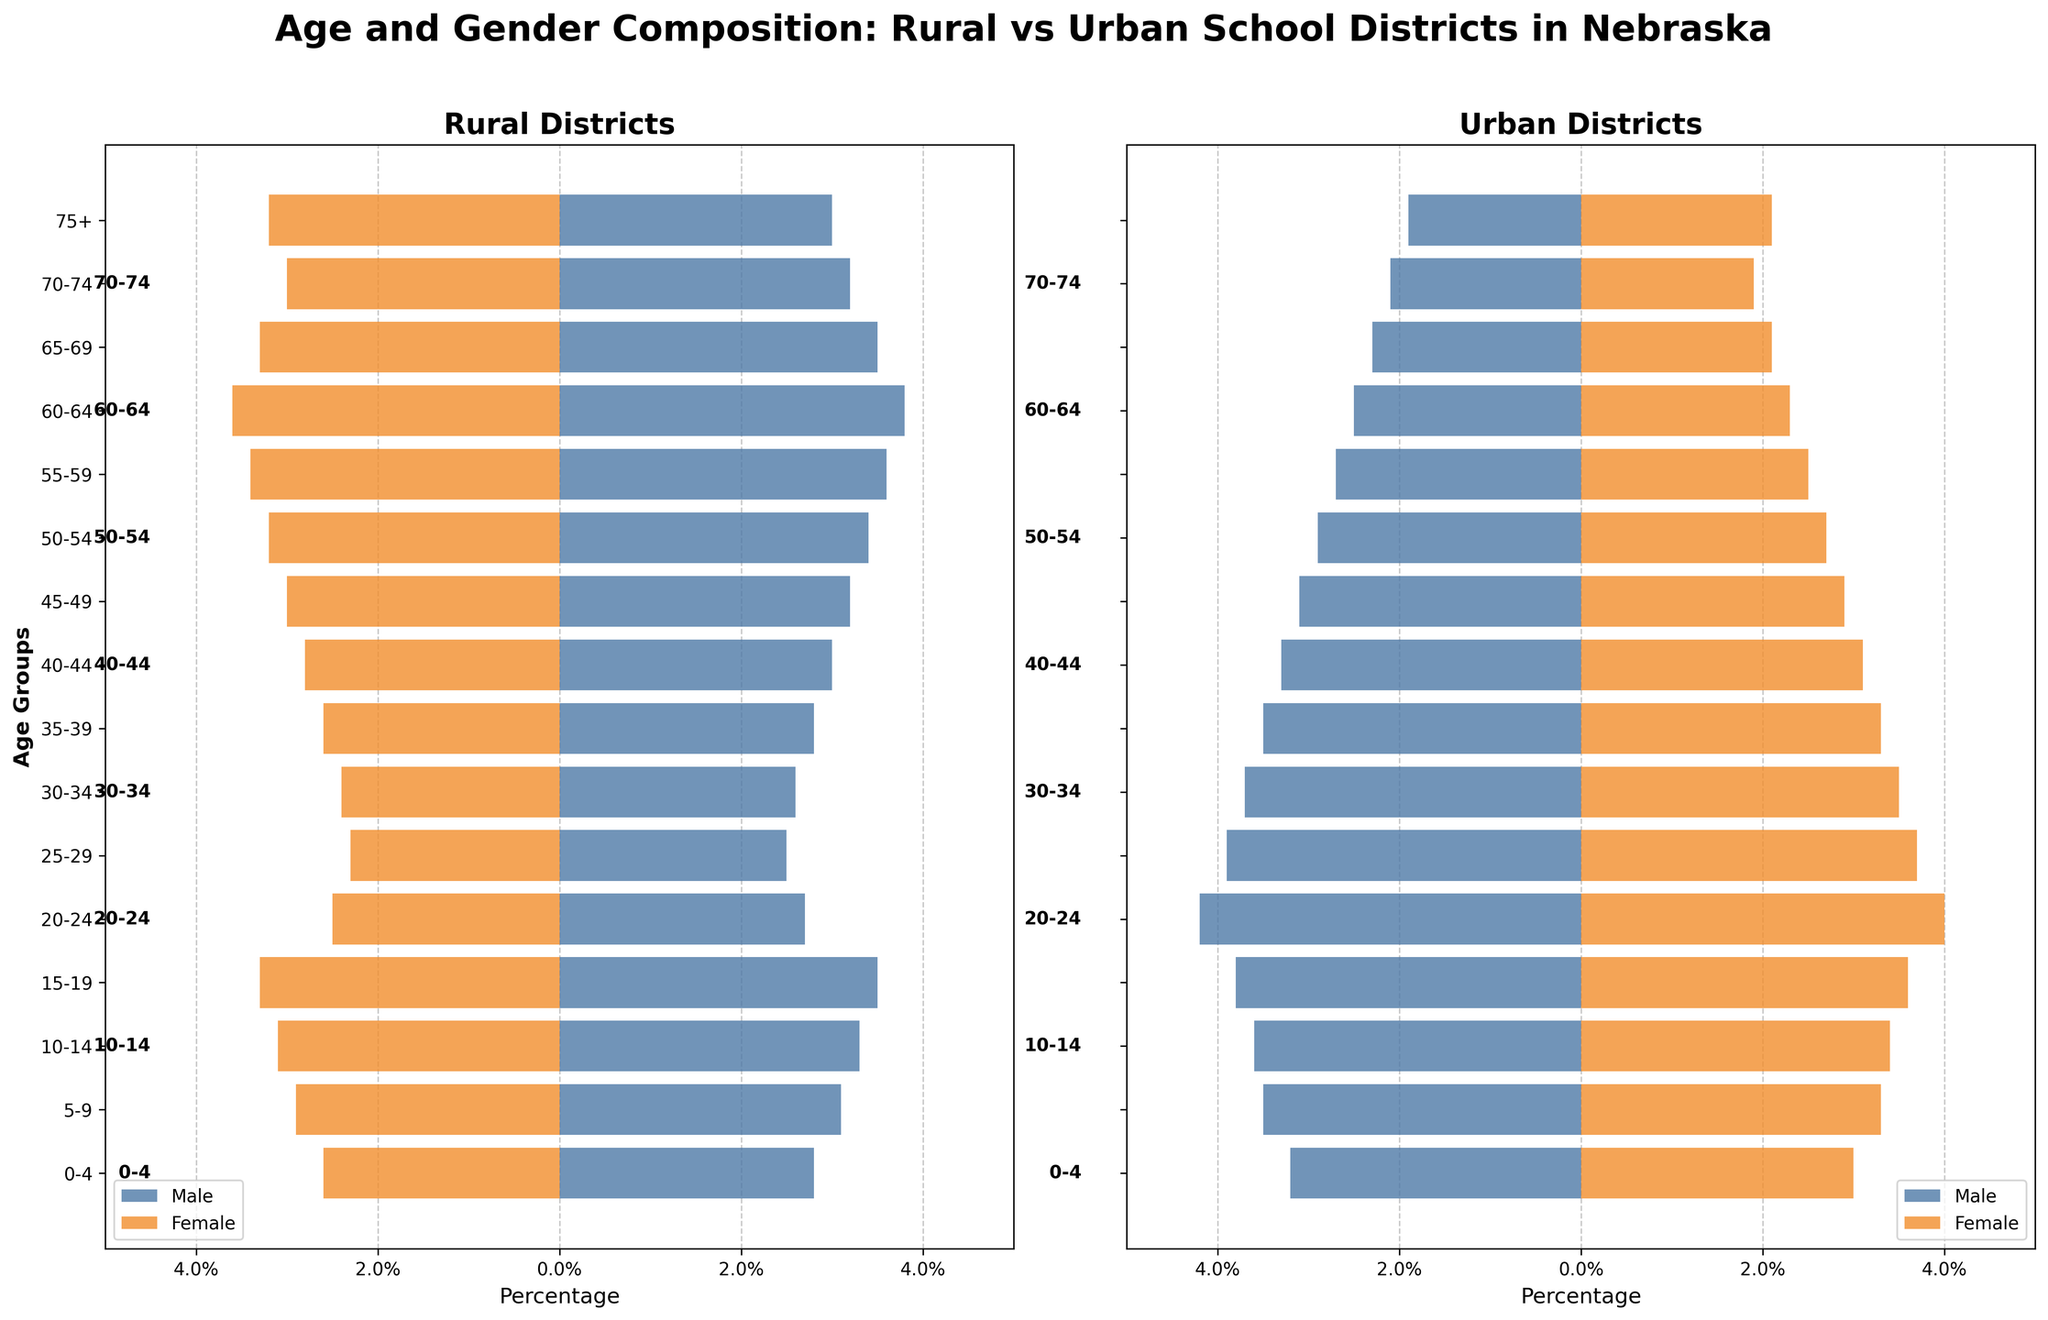What is the title of the figure? The title of the figure can be seen at the top of both subplots, which reads "Age and Gender Composition: Rural vs Urban School Districts in Nebraska".
Answer: Age and Gender Composition: Rural vs Urban School Districts in Nebraska Which district shows a higher percentage of males in the 20-24 age group? Look at the bars corresponding to the 20-24 age group. The percentage of rural males is -2.7% while the percentage of urban males is -4.2%.
Answer: Urban district How does the percentage of rural females aged 5-9 compare with urban females of the same age group? Compare the bars for females in the 5-9 age group. The rural female percentage is 2.9%, while the urban female percentage is 3.3%.
Answer: Urban district has a higher percentage What is the combined percentage of rural males and females aged 60-64? Combine the absolute values of the percentages for rural males (-3.8%) and females (3.6%) in the 60-64 age group: 3.8 + 3.6 = 7.4%.
Answer: 7.4% Which age group has the highest gender disparity in rural districts? Determine the difference between rural male and female percentages for each age group and identify the age group with the largest difference. The age group 60-64 has the largest disparity: 3.8% - 3.6% = 0.2%.
Answer: 60-64 In which age group do urban districts have a higher percentage representation than rural districts for males? Compare the urban male percentages to the rural male percentages in each age group. The 20-24 age group has a higher urban male percentage (4.2%) than the rural male percentage (2.7%).
Answer: 20-24 What is the total percentage of individuals aged 75+ in urban districts? Add the percentages of both males and females in the 75+ age group for urban districts: 1.9% (males) + 2.1% (females) = 4.0%.
Answer: 4.0% Which gender group in rural districts has the highest percentage in any age group? Identify the highest percentage bar for either gender across all age groups in rural districts. Rural males aged 60-64 have the highest percentage at 3.8%.
Answer: Rural males aged 60-64 How does the percentage of urban females aged 25-29 compare with rural females of the same age group? Compare the percentages of urban females and rural females in the 25-29 age group. Urban females have 3.7% while rural females have 2.3%.
Answer: Urban females have a higher percentage For people aged 55-59, what is the difference in percentage between rural and urban males? Subtract the urban male percentage from the rural male percentage for the 55-59 age group: 3.6% - 2.7% = 0.9%.
Answer: 0.9% 